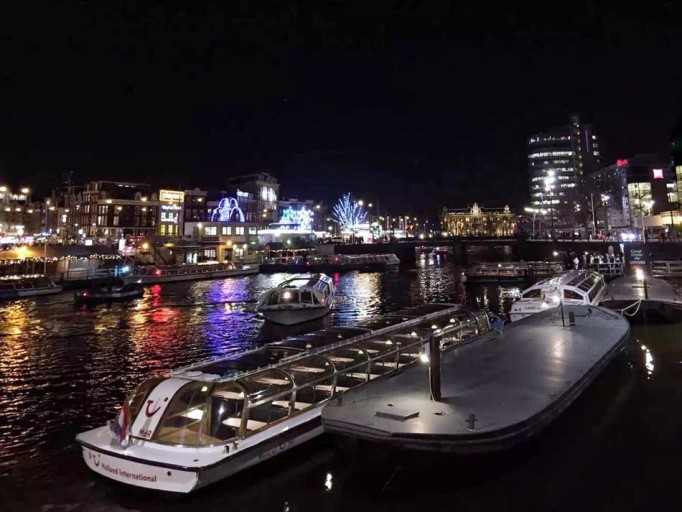What kind of boats are displayed in the image? The picture shows moored passenger boats, likely used for tours or public transportation across the waterways. Their design suggests they are well-equipped to offer comfortable rides to passengers, even in the evening hours. 